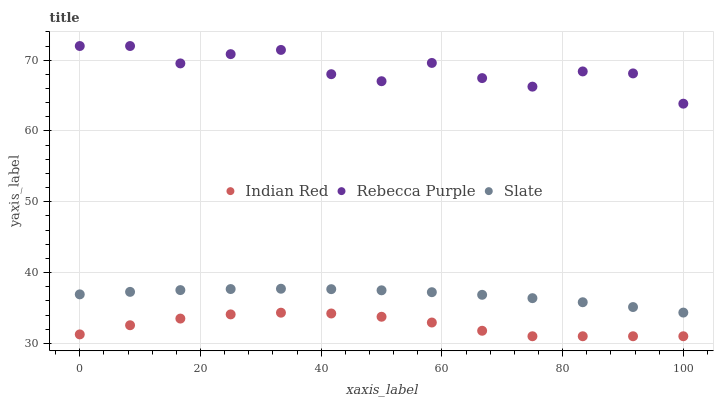Does Indian Red have the minimum area under the curve?
Answer yes or no. Yes. Does Rebecca Purple have the maximum area under the curve?
Answer yes or no. Yes. Does Rebecca Purple have the minimum area under the curve?
Answer yes or no. No. Does Indian Red have the maximum area under the curve?
Answer yes or no. No. Is Slate the smoothest?
Answer yes or no. Yes. Is Rebecca Purple the roughest?
Answer yes or no. Yes. Is Indian Red the smoothest?
Answer yes or no. No. Is Indian Red the roughest?
Answer yes or no. No. Does Indian Red have the lowest value?
Answer yes or no. Yes. Does Rebecca Purple have the lowest value?
Answer yes or no. No. Does Rebecca Purple have the highest value?
Answer yes or no. Yes. Does Indian Red have the highest value?
Answer yes or no. No. Is Indian Red less than Rebecca Purple?
Answer yes or no. Yes. Is Rebecca Purple greater than Indian Red?
Answer yes or no. Yes. Does Indian Red intersect Rebecca Purple?
Answer yes or no. No. 